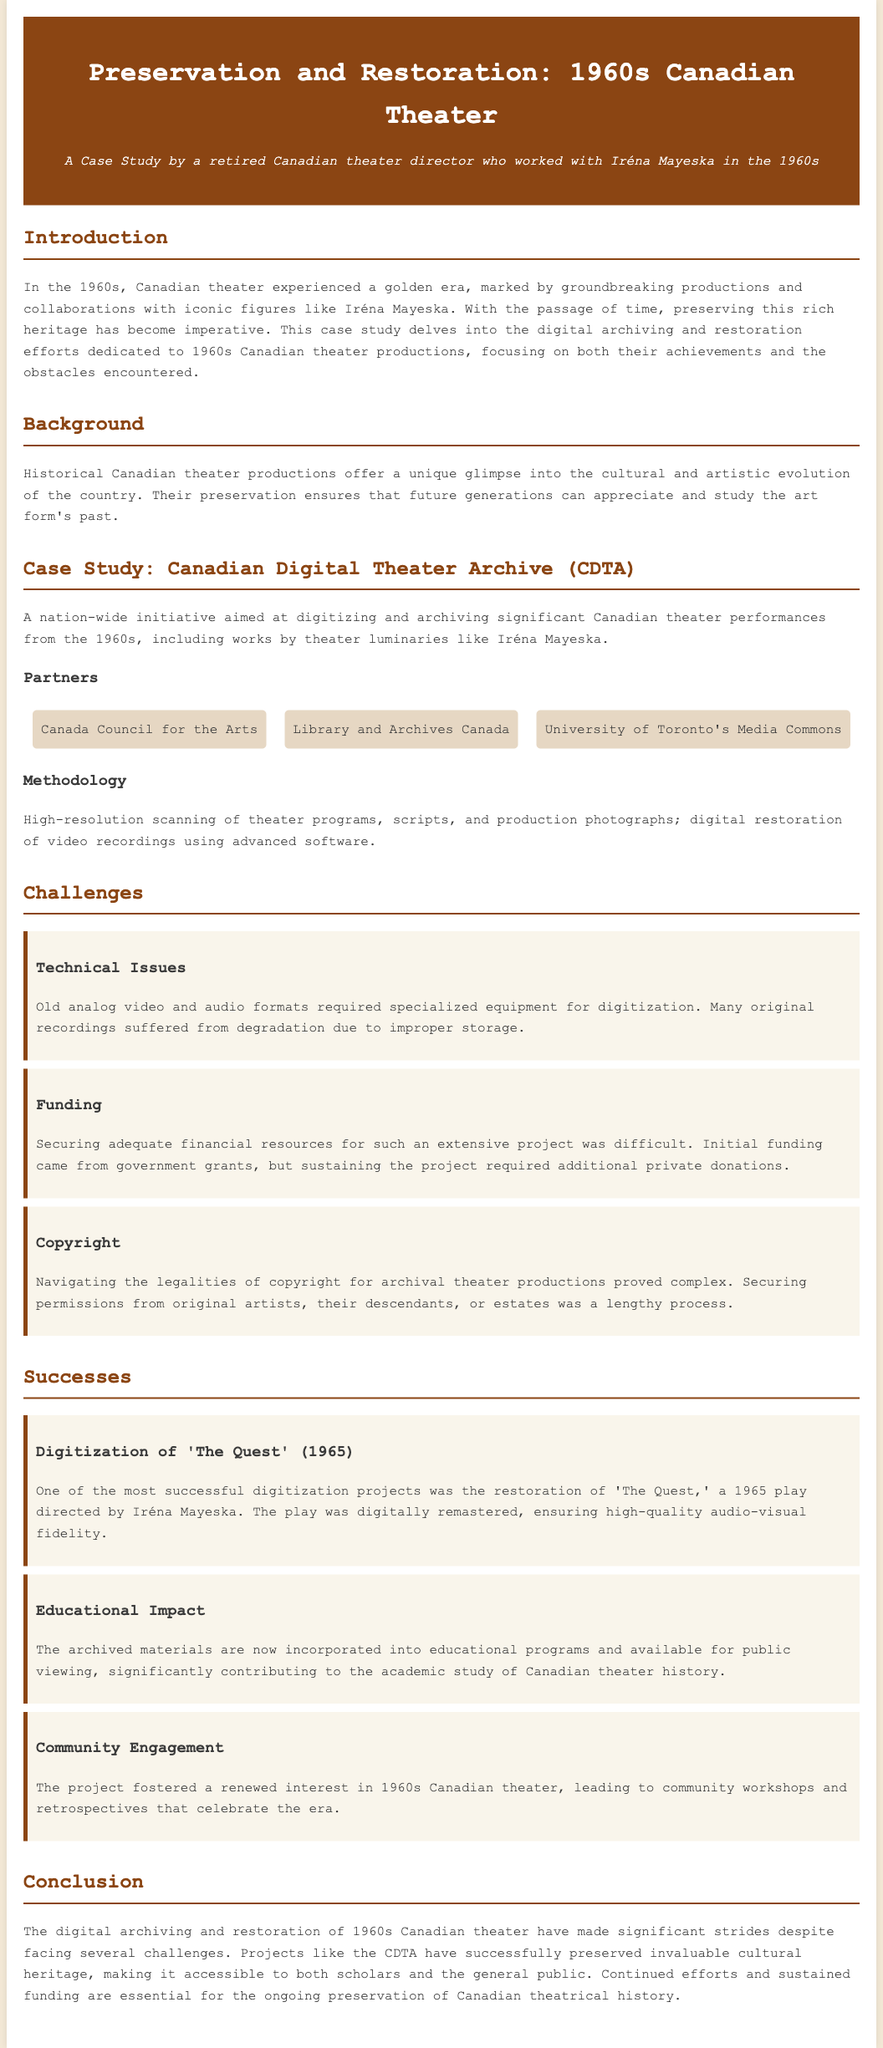what is the title of the case study? The title of the case study is stated prominently at the top of the document.
Answer: Preservation and Restoration: 1960s Canadian Theater who collaborated on the Canadian Digital Theater Archive? The documentation lists key partners involved in the initiative.
Answer: Canada Council for the Arts, Library and Archives Canada, University of Toronto's Media Commons what was a major technical challenge mentioned in the restoration efforts? The document highlights specific difficulties in the process of digitization.
Answer: Technical Issues what year was 'The Quest' performed? The document includes the release year of this significant theater production.
Answer: 1965 what impact did the archived materials have on education? The success section details the benefits of archiving for education.
Answer: Educational Impact how did the preservation project engage the community? The document describes activities that fostered interest in the 1960s theater.
Answer: Community Engagement what was the primary methodology used for digitization? The case study details the methodological approach taken in the project.
Answer: High-resolution scanning how many challenges are listed in the document? The challenges section enumerates the difficulties encountered in the project.
Answer: Three 